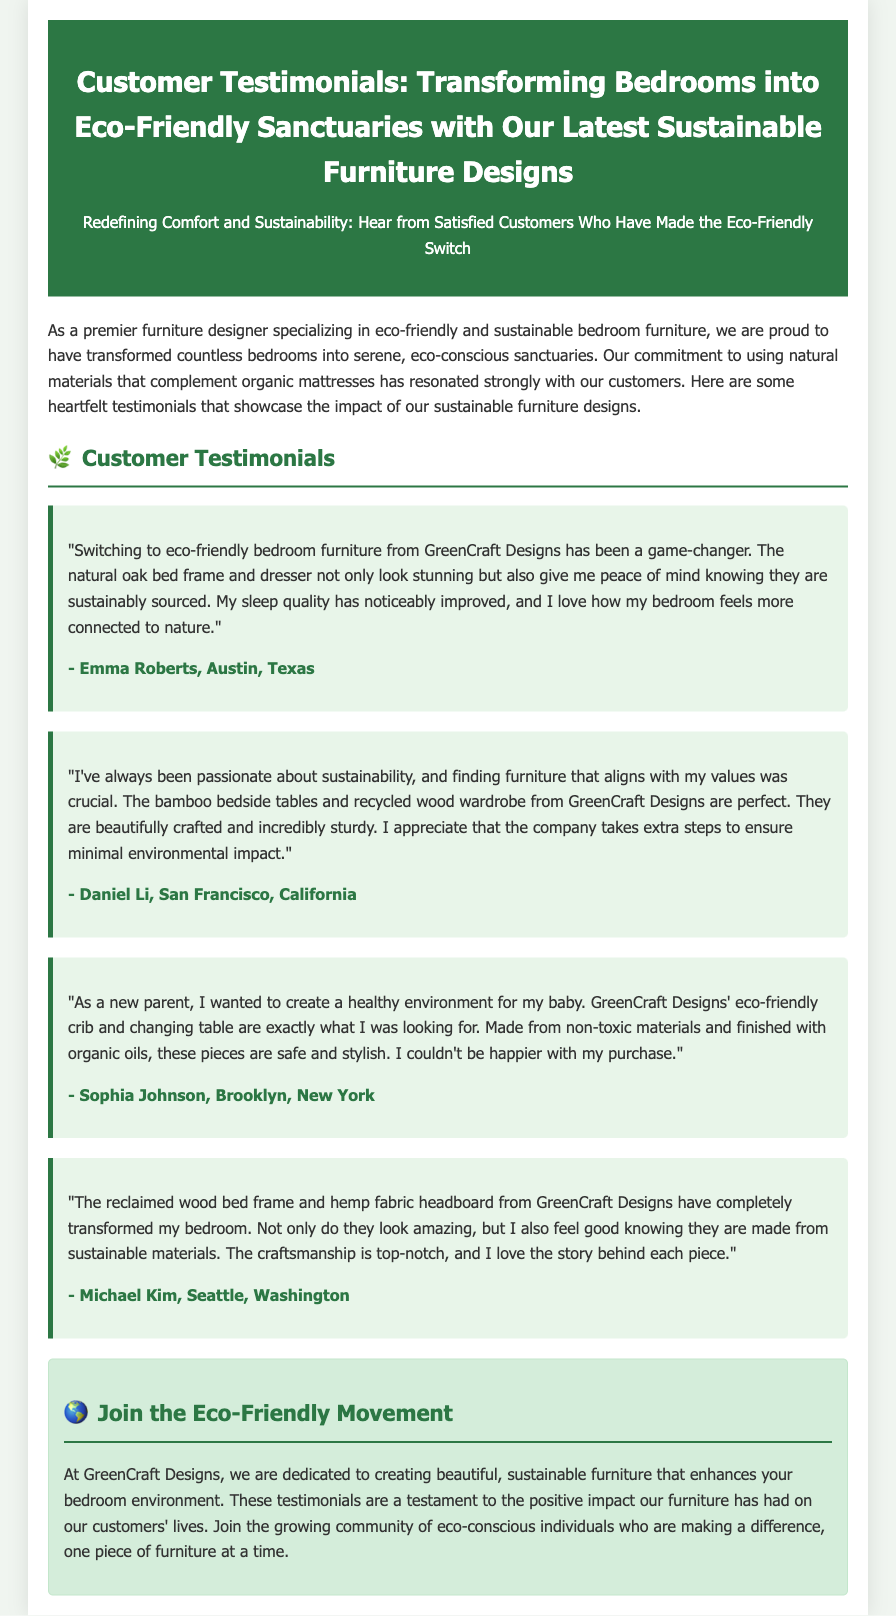What is the title of the press release? The title of the press release provides the main subject matter, which is about customer testimonials regarding eco-friendly bedroom furniture.
Answer: Customer Testimonials: Transforming Bedrooms into Eco-Friendly Sanctuaries with Our Latest Sustainable Furniture Designs Who designed the eco-friendly furniture mentioned in the document? The document states that GreenCraft Designs is the premier furniture designer specializing in eco-friendly furniture.
Answer: GreenCraft Designs How many customer testimonials are featured in the document? The document includes four separate customer testimonials that highlight their experiences with the furniture.
Answer: Four Which material is mentioned as being used for the bedside tables? The document specifies bamboo as the material used for the bedside tables in one of the testimonials.
Answer: Bamboo What is one of the benefits of the eco-friendly crib mentioned by a customer? The document mentions that the eco-friendly crib is made from non-toxic materials, making it safe for babies.
Answer: Non-toxic materials Why did Daniel Li choose GreenCraft Designs' furniture? Daniel Li valued sustainability and sought furniture that aligned with his values.
Answer: Sustainability What type of fabric is used in the headboard mentioned by Michael Kim? The headboard mentioned by Michael Kim is made from hemp fabric.
Answer: Hemp fabric What feeling does Emma Roberts express about her bedroom after using GreenCraft Designs furniture? Emma Roberts states that her bedroom feels more connected to nature after the switch.
Answer: Connected to nature 